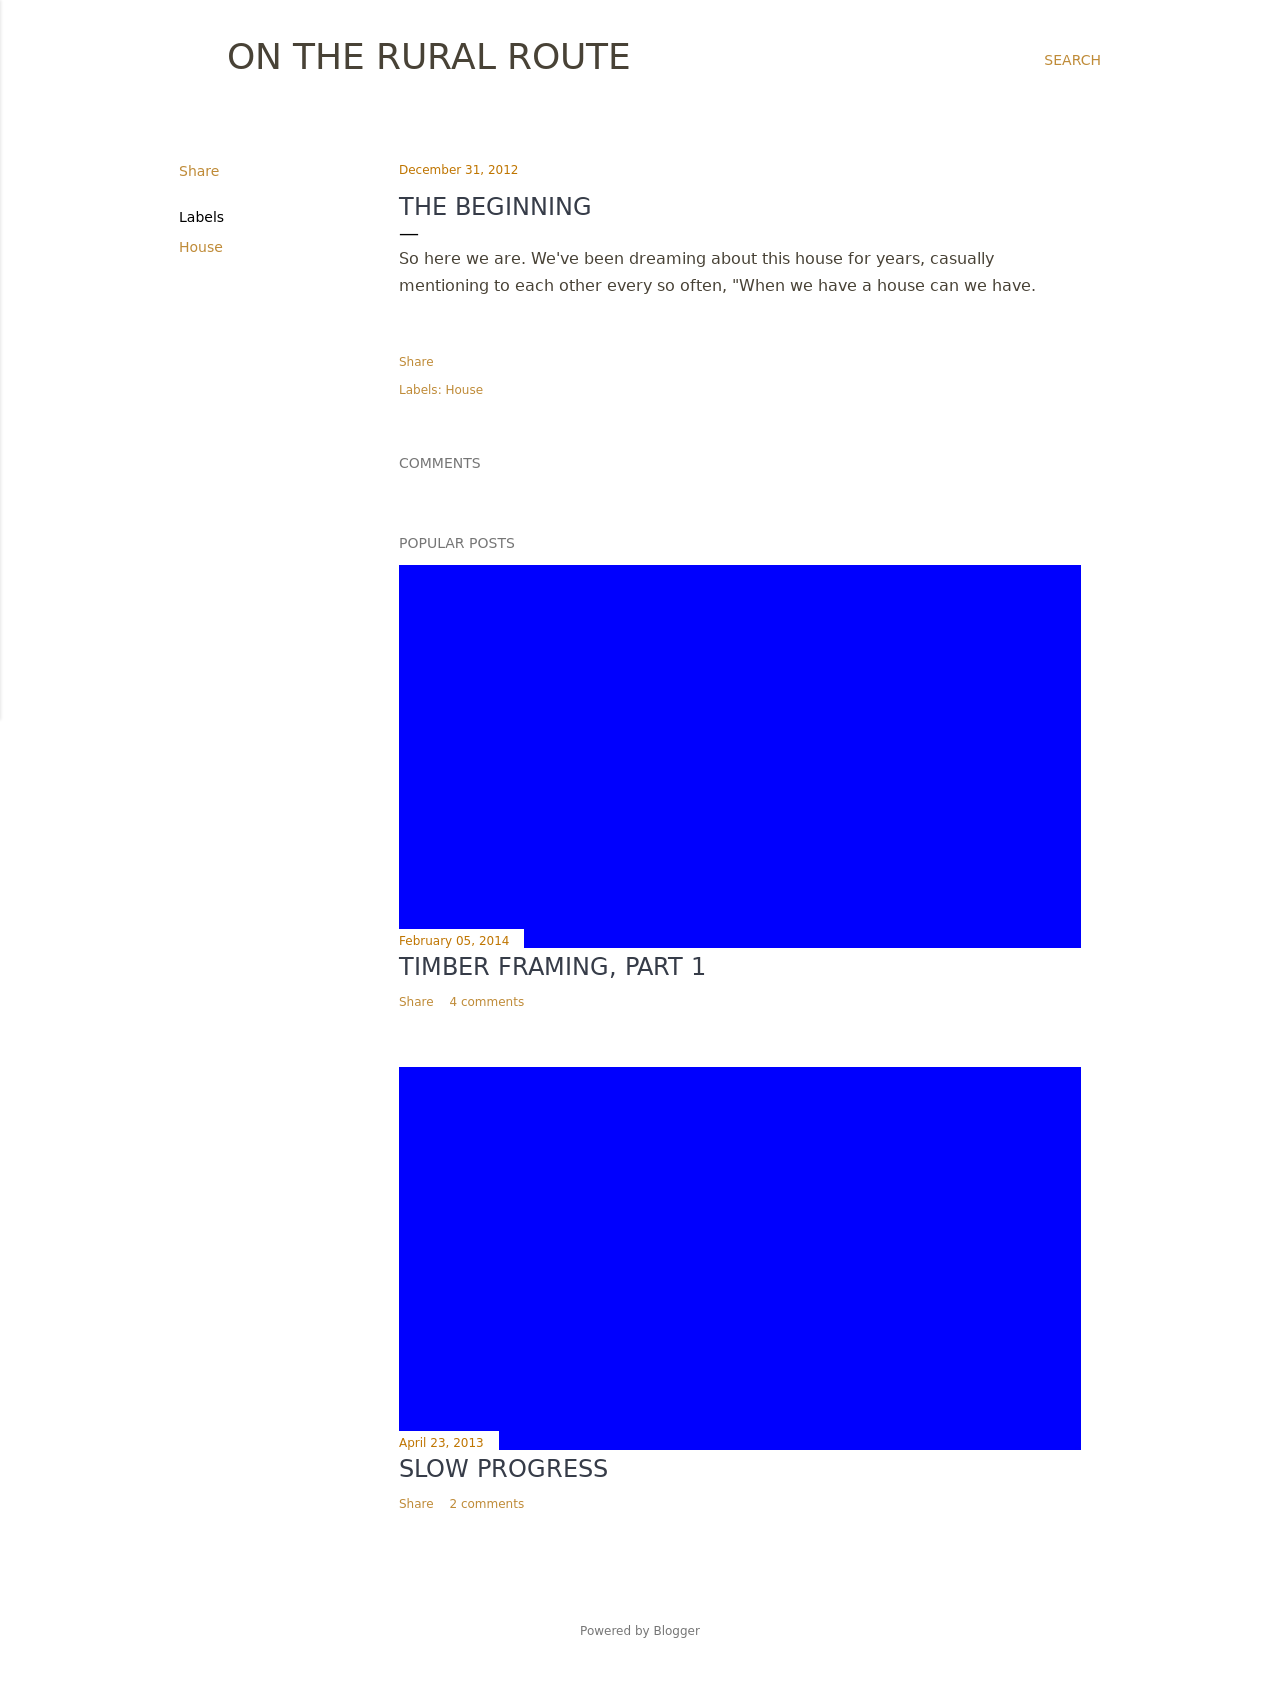How can I start building this website with HTML from the ground up? To build a blog-like website shown in the image, you'll start by structuring your HTML to contain headers, main content areas, and sidebars. Use semantic tags like <header>, <main>, and <aside> for a basic layout. CSS will be essential for styling, so refer to creating a CSS file linked in your HTML's <head>. Begin with defining global styles, such as font and background colors, then add specific styles for your headers, posts, and sidebar. Utilize <div> tags to segment each blog post and use classes to style their appearance. Lastly, ensure to make your website responsive by using media queries in your CSS to adjust to different screen sizes. 